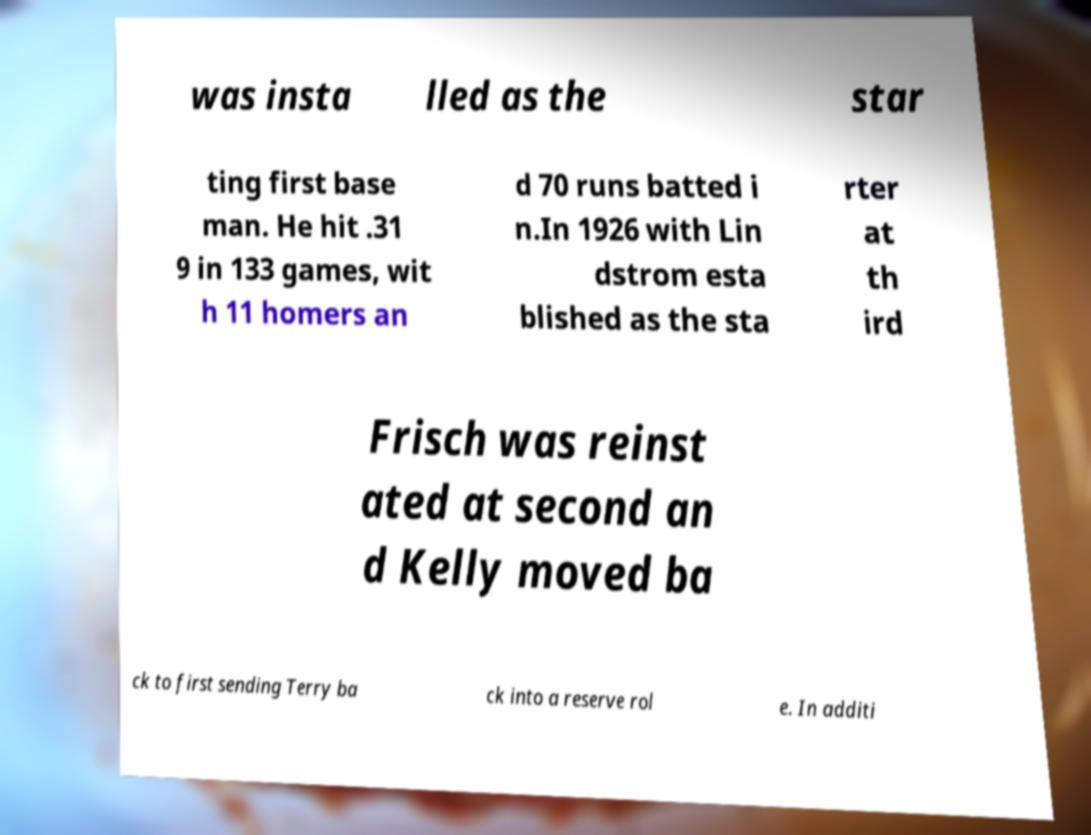What messages or text are displayed in this image? I need them in a readable, typed format. was insta lled as the star ting first base man. He hit .31 9 in 133 games, wit h 11 homers an d 70 runs batted i n.In 1926 with Lin dstrom esta blished as the sta rter at th ird Frisch was reinst ated at second an d Kelly moved ba ck to first sending Terry ba ck into a reserve rol e. In additi 